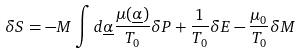<formula> <loc_0><loc_0><loc_500><loc_500>\delta S = - M \int d \underline { \alpha } \frac { \mu ( \underline { \alpha } ) } { T _ { 0 } } \delta P + \frac { 1 } { T _ { 0 } } \delta E - \frac { \mu _ { 0 } } { T _ { 0 } } \delta M</formula> 